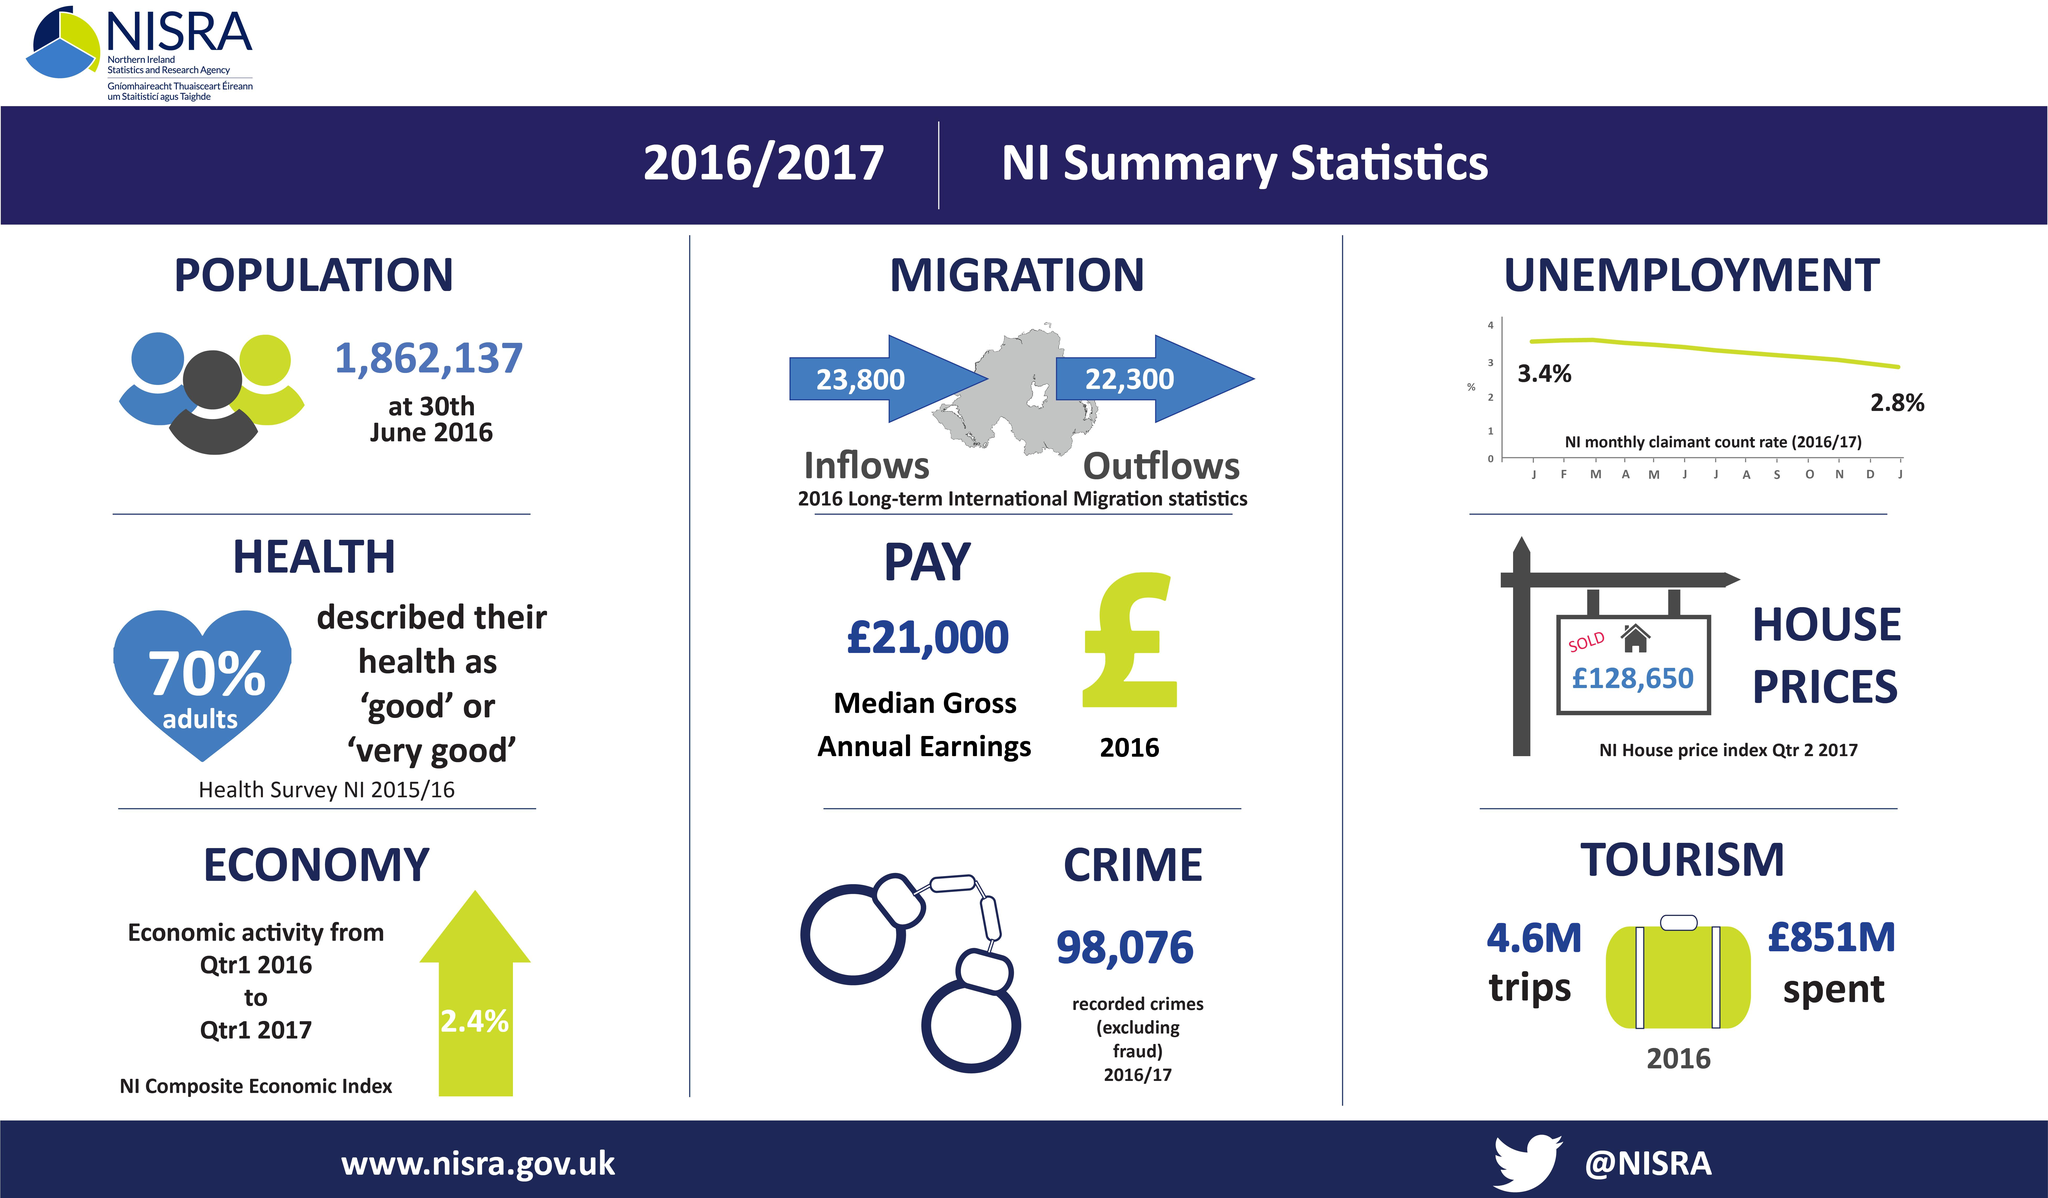Specify some key components in this picture. In 2016, 23,800 individuals migrated to Northern Ireland. In 2016, it is estimated that approximately 22,300 individuals left Northern Ireland. Approximately 30% of adults in Northern Ireland have not marked their health condition as "good" or "very good" on a recent survey. 